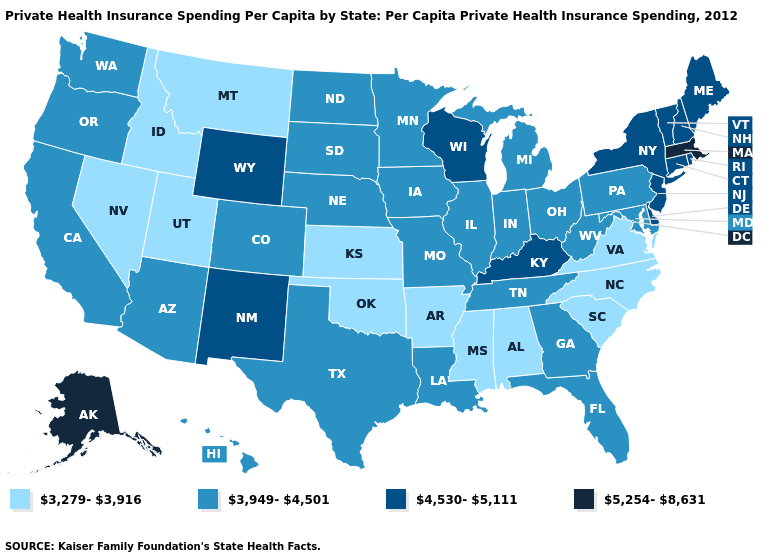Does Oregon have a lower value than Connecticut?
Write a very short answer. Yes. What is the lowest value in the West?
Give a very brief answer. 3,279-3,916. Name the states that have a value in the range 3,279-3,916?
Write a very short answer. Alabama, Arkansas, Idaho, Kansas, Mississippi, Montana, Nevada, North Carolina, Oklahoma, South Carolina, Utah, Virginia. What is the value of South Dakota?
Short answer required. 3,949-4,501. What is the highest value in the USA?
Concise answer only. 5,254-8,631. Among the states that border Pennsylvania , which have the lowest value?
Short answer required. Maryland, Ohio, West Virginia. Among the states that border Vermont , which have the highest value?
Answer briefly. Massachusetts. Does North Carolina have a lower value than Oregon?
Be succinct. Yes. What is the value of Georgia?
Give a very brief answer. 3,949-4,501. Name the states that have a value in the range 4,530-5,111?
Give a very brief answer. Connecticut, Delaware, Kentucky, Maine, New Hampshire, New Jersey, New Mexico, New York, Rhode Island, Vermont, Wisconsin, Wyoming. What is the value of Alabama?
Answer briefly. 3,279-3,916. What is the value of Vermont?
Short answer required. 4,530-5,111. Does the map have missing data?
Write a very short answer. No. Does Wyoming have the lowest value in the West?
Give a very brief answer. No. Which states hav the highest value in the Northeast?
Concise answer only. Massachusetts. 